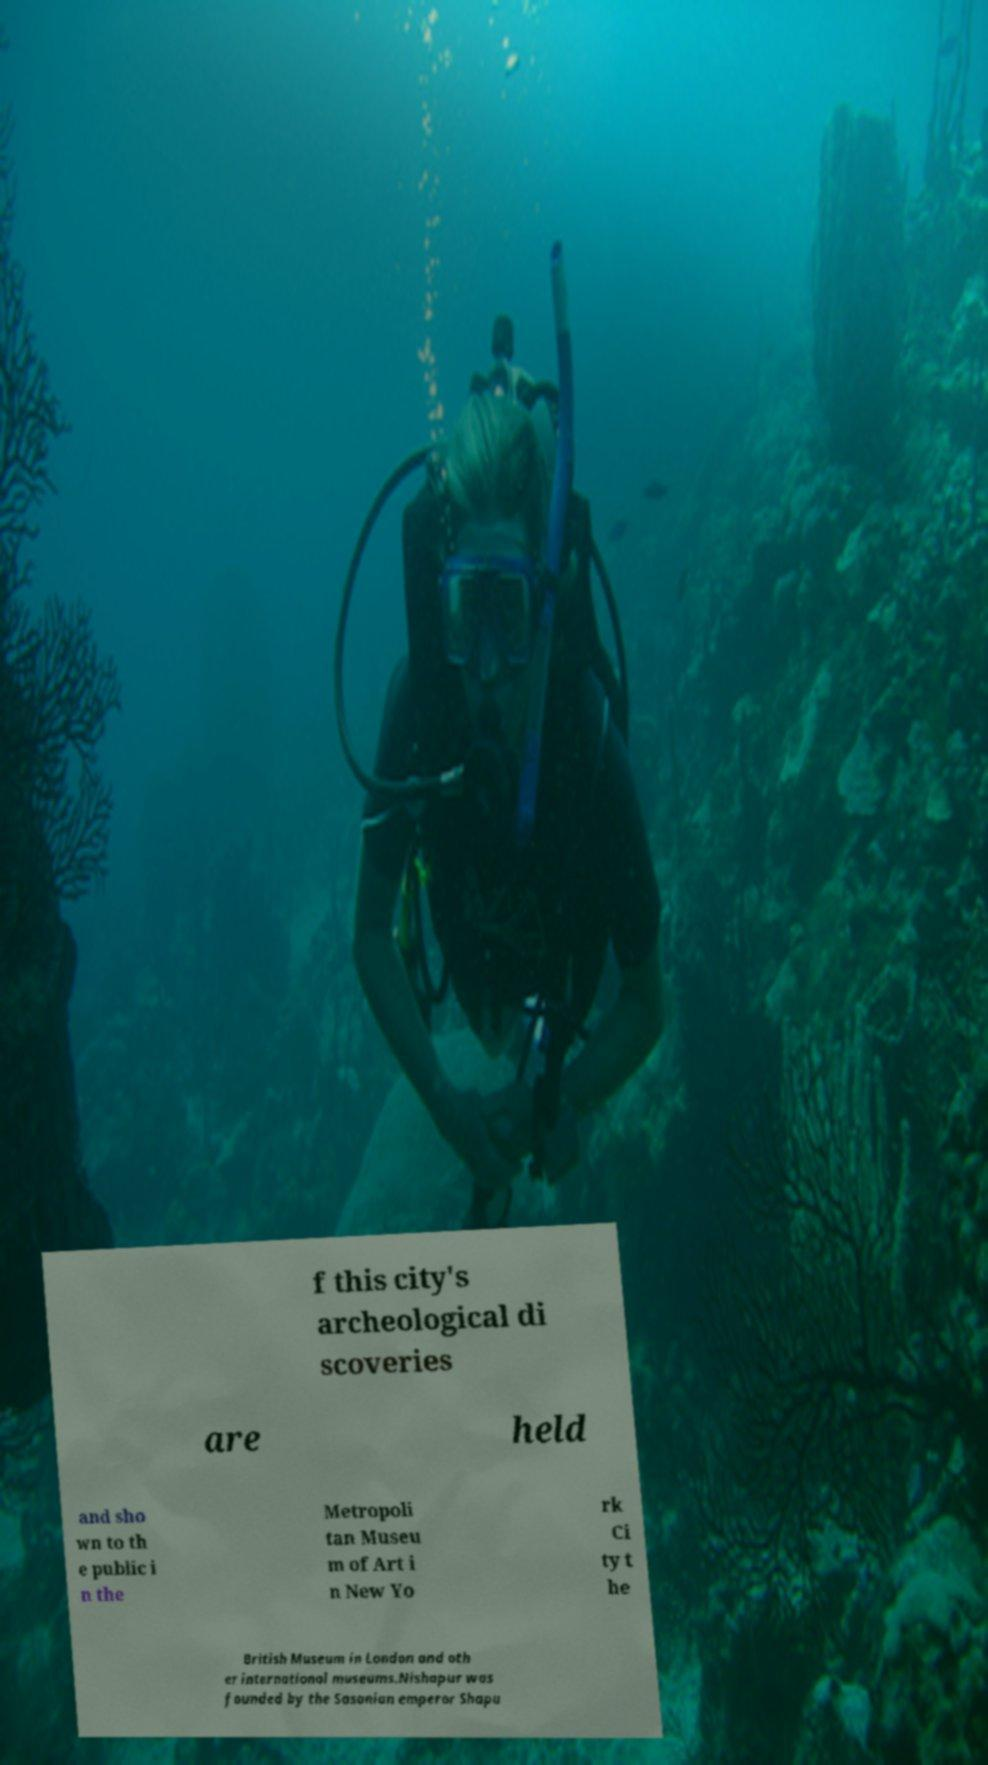Please identify and transcribe the text found in this image. f this city's archeological di scoveries are held and sho wn to th e public i n the Metropoli tan Museu m of Art i n New Yo rk Ci ty t he British Museum in London and oth er international museums.Nishapur was founded by the Sasanian emperor Shapu 